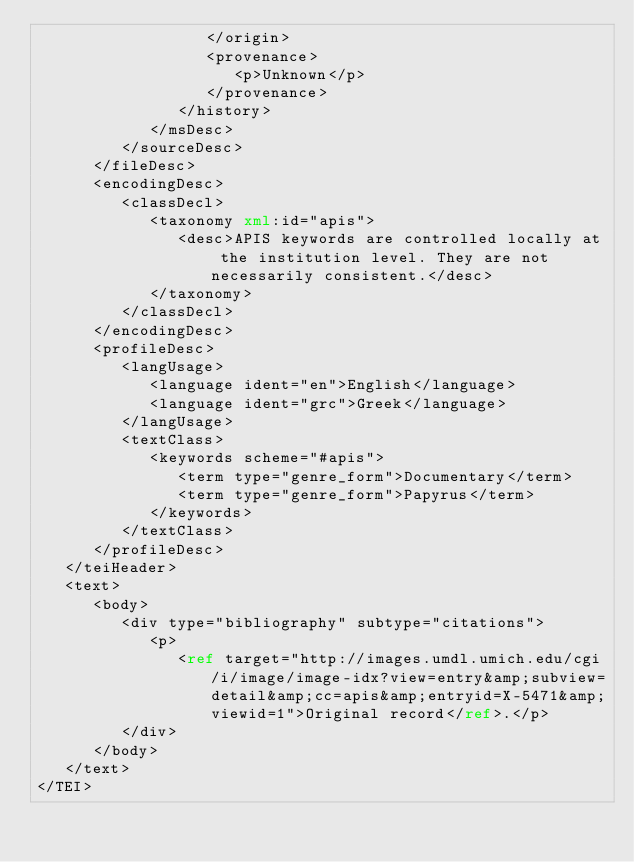<code> <loc_0><loc_0><loc_500><loc_500><_XML_>                  </origin>
                  <provenance>
                     <p>Unknown</p>
                  </provenance>
               </history>
            </msDesc>
         </sourceDesc>
      </fileDesc>
      <encodingDesc>
         <classDecl>
            <taxonomy xml:id="apis">
               <desc>APIS keywords are controlled locally at the institution level. They are not necessarily consistent.</desc>
            </taxonomy>
         </classDecl>
      </encodingDesc>
      <profileDesc>
         <langUsage>
            <language ident="en">English</language>
            <language ident="grc">Greek</language>
         </langUsage>
         <textClass>
            <keywords scheme="#apis">
               <term type="genre_form">Documentary</term>
               <term type="genre_form">Papyrus</term>
            </keywords>
         </textClass>
      </profileDesc>
   </teiHeader>
   <text>
      <body>
         <div type="bibliography" subtype="citations">
            <p>
               <ref target="http://images.umdl.umich.edu/cgi/i/image/image-idx?view=entry&amp;subview=detail&amp;cc=apis&amp;entryid=X-5471&amp;viewid=1">Original record</ref>.</p>
         </div>
      </body>
   </text>
</TEI>
</code> 